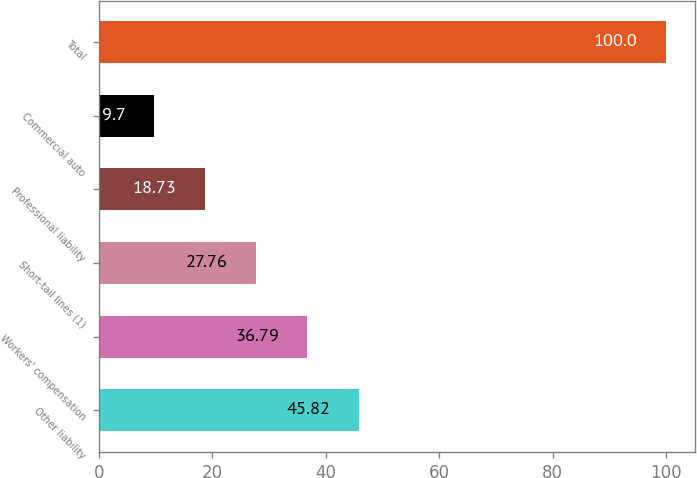Convert chart. <chart><loc_0><loc_0><loc_500><loc_500><bar_chart><fcel>Other liability<fcel>Workers' compensation<fcel>Short-tail lines (1)<fcel>Professional liability<fcel>Commercial auto<fcel>Total<nl><fcel>45.82<fcel>36.79<fcel>27.76<fcel>18.73<fcel>9.7<fcel>100<nl></chart> 